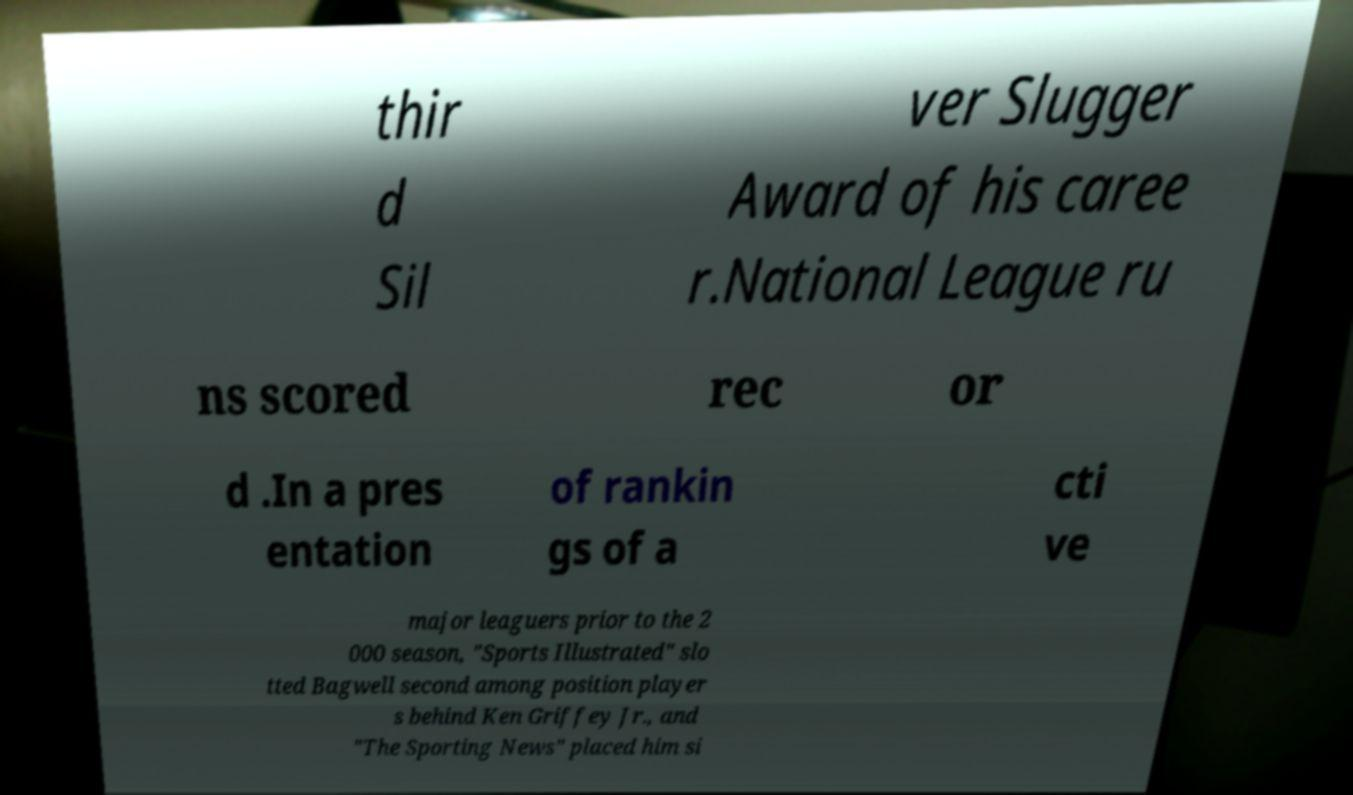Could you extract and type out the text from this image? thir d Sil ver Slugger Award of his caree r.National League ru ns scored rec or d .In a pres entation of rankin gs of a cti ve major leaguers prior to the 2 000 season, "Sports Illustrated" slo tted Bagwell second among position player s behind Ken Griffey Jr., and "The Sporting News" placed him si 